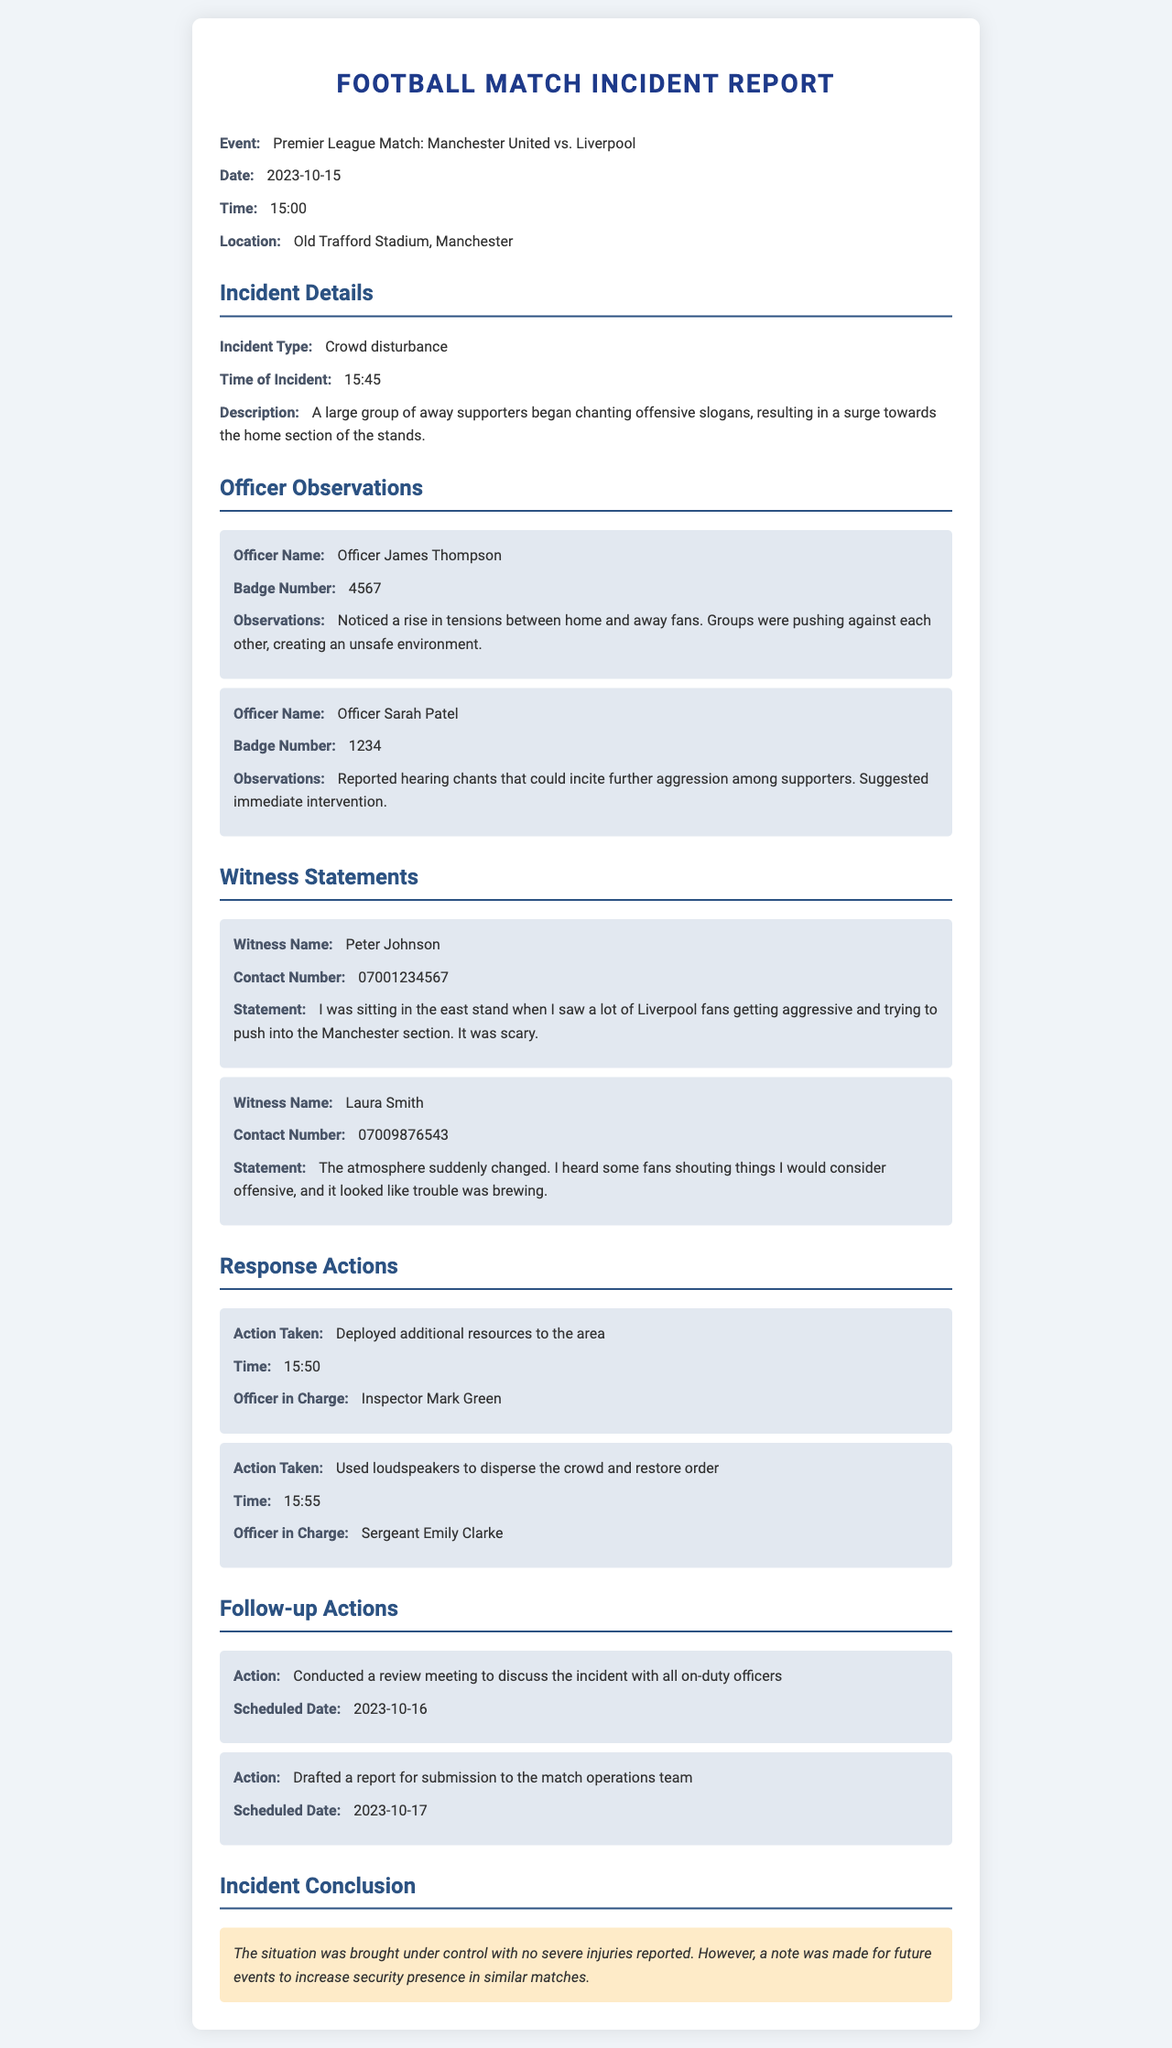What is the event name? The event name is specified in the document under the "Event" section, which is "Premier League Match: Manchester United vs. Liverpool."
Answer: Premier League Match: Manchester United vs. Liverpool What type of incident occurred? The type of incident is indicated under "Incident Details," which states "Crowd disturbance."
Answer: Crowd disturbance What time did the incident take place? The time of the incident is mentioned in "Incident Details" as "15:45."
Answer: 15:45 Who was the officer in charge of dispersing the crowd? The officer in charge of the action to disperse the crowd is indicated under "Response Actions," which is "Sergeant Emily Clarke."
Answer: Sergeant Emily Clarke What was one of the witness statements? A witness statement includes personal observations about the incident; one such statement is "I was sitting in the east stand when I saw a lot of Liverpool fans getting aggressive."
Answer: I was sitting in the east stand when I saw a lot of Liverpool fans getting aggressive What was the response action taken at 15:50? The document lists specific actions taken in response to the incident; one action at 15:50 was to deploy additional resources to the area.
Answer: Deployed additional resources to the area When is the review meeting scheduled? The scheduled date for the review meeting is in "Follow-up Actions," which states "2023-10-16."
Answer: 2023-10-16 What conclusion was drawn regarding future events? The conclusion about future events is highlighted in "Incident Conclusion", which suggests to increase security presence.
Answer: Increase security presence in similar matches 